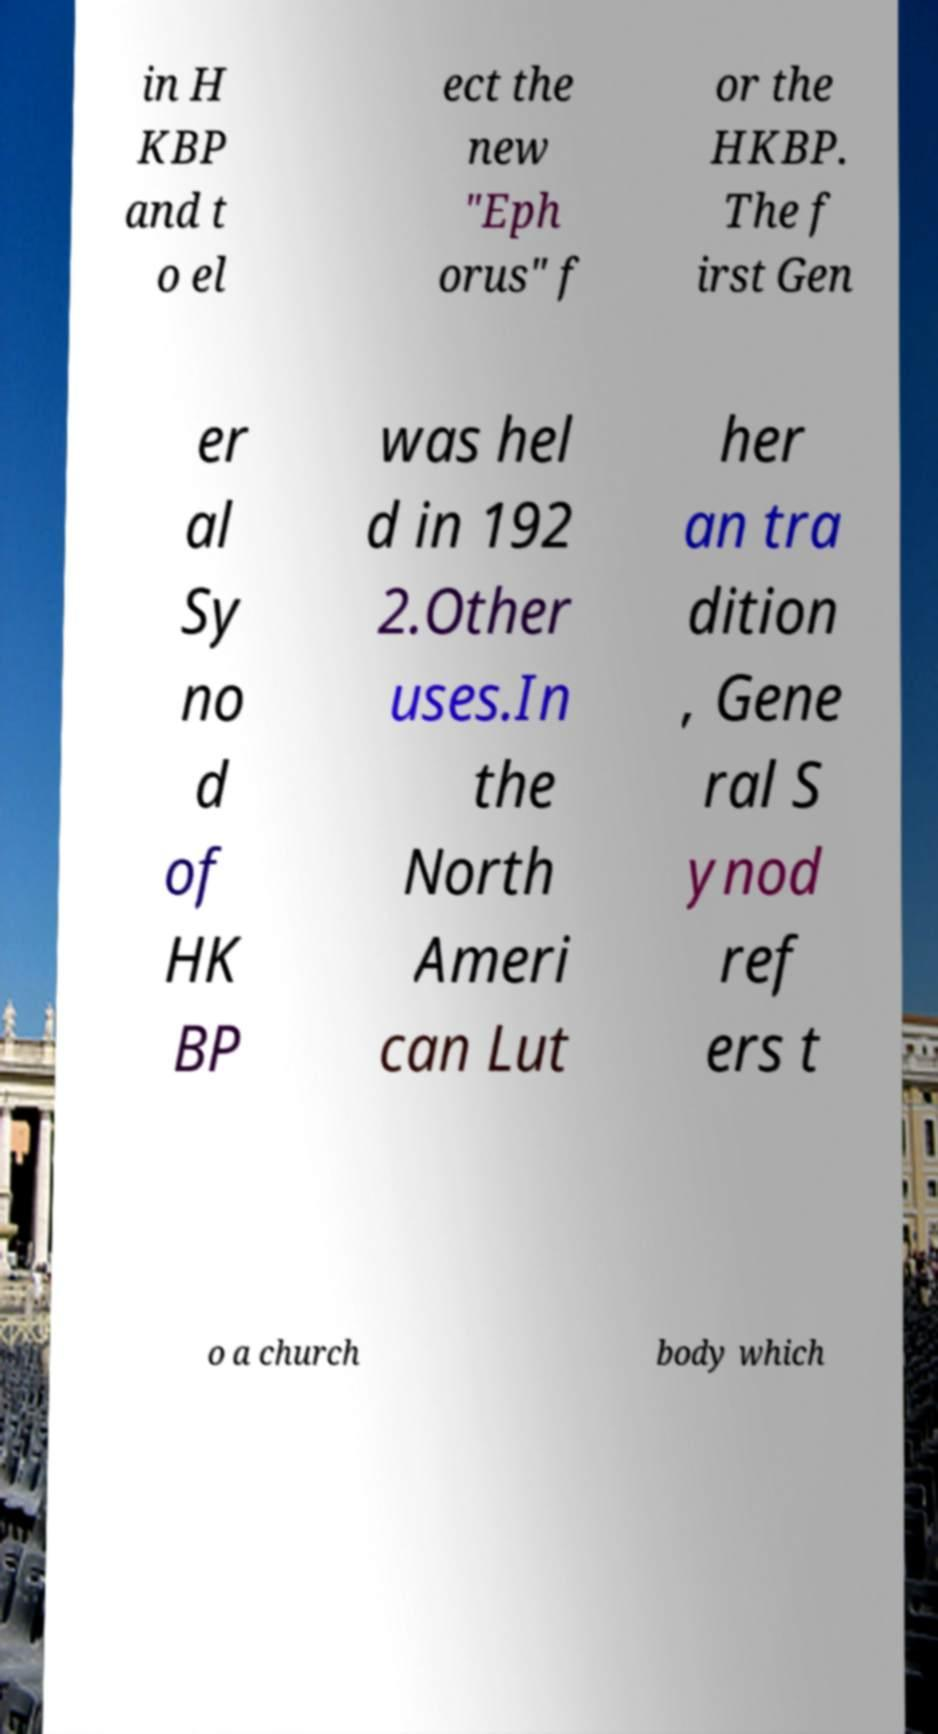Could you assist in decoding the text presented in this image and type it out clearly? in H KBP and t o el ect the new "Eph orus" f or the HKBP. The f irst Gen er al Sy no d of HK BP was hel d in 192 2.Other uses.In the North Ameri can Lut her an tra dition , Gene ral S ynod ref ers t o a church body which 